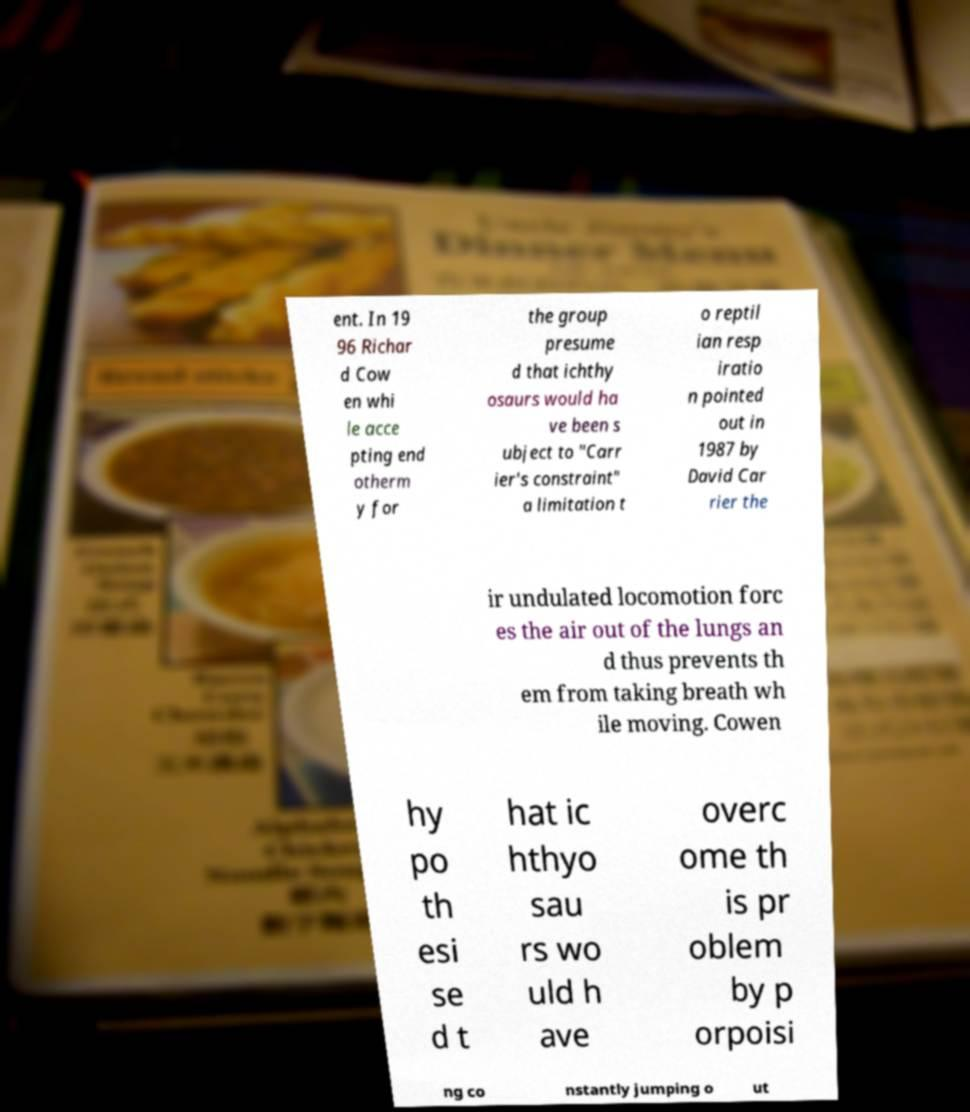There's text embedded in this image that I need extracted. Can you transcribe it verbatim? ent. In 19 96 Richar d Cow en whi le acce pting end otherm y for the group presume d that ichthy osaurs would ha ve been s ubject to "Carr ier's constraint" a limitation t o reptil ian resp iratio n pointed out in 1987 by David Car rier the ir undulated locomotion forc es the air out of the lungs an d thus prevents th em from taking breath wh ile moving. Cowen hy po th esi se d t hat ic hthyo sau rs wo uld h ave overc ome th is pr oblem by p orpoisi ng co nstantly jumping o ut 